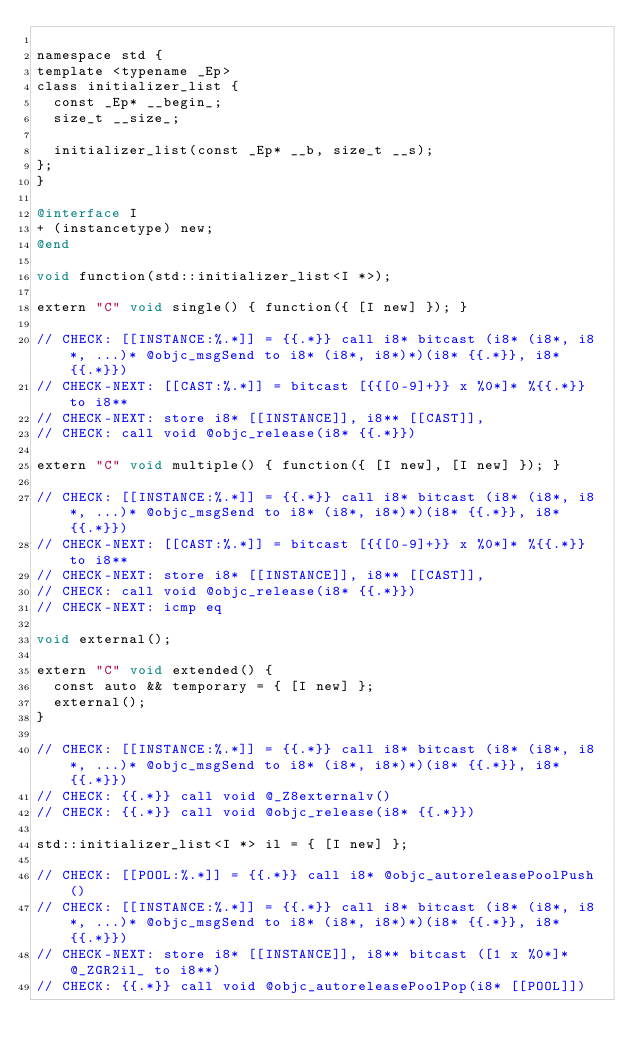Convert code to text. <code><loc_0><loc_0><loc_500><loc_500><_ObjectiveC_>
namespace std {
template <typename _Ep>
class initializer_list {
  const _Ep* __begin_;
  size_t __size_;

  initializer_list(const _Ep* __b, size_t __s);
};
}

@interface I
+ (instancetype) new;
@end

void function(std::initializer_list<I *>);

extern "C" void single() { function({ [I new] }); }

// CHECK: [[INSTANCE:%.*]] = {{.*}} call i8* bitcast (i8* (i8*, i8*, ...)* @objc_msgSend to i8* (i8*, i8*)*)(i8* {{.*}}, i8* {{.*}})
// CHECK-NEXT: [[CAST:%.*]] = bitcast [{{[0-9]+}} x %0*]* %{{.*}} to i8**
// CHECK-NEXT: store i8* [[INSTANCE]], i8** [[CAST]],
// CHECK: call void @objc_release(i8* {{.*}})

extern "C" void multiple() { function({ [I new], [I new] }); }

// CHECK: [[INSTANCE:%.*]] = {{.*}} call i8* bitcast (i8* (i8*, i8*, ...)* @objc_msgSend to i8* (i8*, i8*)*)(i8* {{.*}}, i8* {{.*}})
// CHECK-NEXT: [[CAST:%.*]] = bitcast [{{[0-9]+}} x %0*]* %{{.*}} to i8**
// CHECK-NEXT: store i8* [[INSTANCE]], i8** [[CAST]],
// CHECK: call void @objc_release(i8* {{.*}})
// CHECK-NEXT: icmp eq

void external();

extern "C" void extended() {
  const auto && temporary = { [I new] };
  external();
}

// CHECK: [[INSTANCE:%.*]] = {{.*}} call i8* bitcast (i8* (i8*, i8*, ...)* @objc_msgSend to i8* (i8*, i8*)*)(i8* {{.*}}, i8* {{.*}})
// CHECK: {{.*}} call void @_Z8externalv()
// CHECK: {{.*}} call void @objc_release(i8* {{.*}})

std::initializer_list<I *> il = { [I new] };

// CHECK: [[POOL:%.*]] = {{.*}} call i8* @objc_autoreleasePoolPush()
// CHECK: [[INSTANCE:%.*]] = {{.*}} call i8* bitcast (i8* (i8*, i8*, ...)* @objc_msgSend to i8* (i8*, i8*)*)(i8* {{.*}}, i8* {{.*}})
// CHECK-NEXT: store i8* [[INSTANCE]], i8** bitcast ([1 x %0*]* @_ZGR2il_ to i8**)
// CHECK: {{.*}} call void @objc_autoreleasePoolPop(i8* [[POOL]])

</code> 